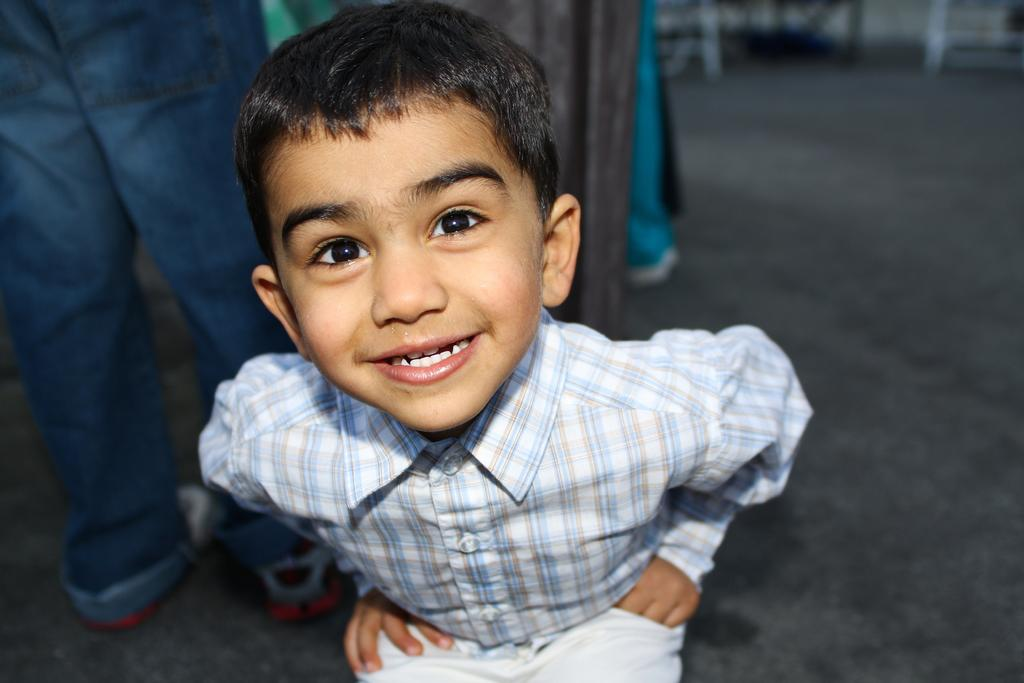What is the main subject in the foreground of the image? There is a child in the foreground of the image. What can be seen in the background of the image? There are people in the background of the image. What type of surface is visible in the image? The floor is visible in the image. What type of steel is being used to create the dinner table in the image? There is no dinner table present in the image, and therefore no steel can be observed. 